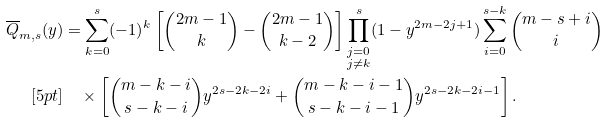Convert formula to latex. <formula><loc_0><loc_0><loc_500><loc_500>\overline { Q } _ { m , s } ( y ) & = \sum _ { k = 0 } ^ { s } ( - 1 ) ^ { k } \left [ { 2 m - 1 \choose k } - { 2 m - 1 \choose k - 2 } \right ] \prod _ { \substack { j = 0 \\ j \neq k } } ^ { s } ( 1 - y ^ { 2 m - 2 j + 1 } ) \sum _ { i = 0 } ^ { s - k } { m - s + i \choose i } \\ [ 5 p t ] & \quad \times \left [ { m - k - i \choose s - k - i } y ^ { 2 s - 2 k - 2 i } + { m - k - i - 1 \choose s - k - i - 1 } y ^ { 2 s - 2 k - 2 i - 1 } \right ] .</formula> 